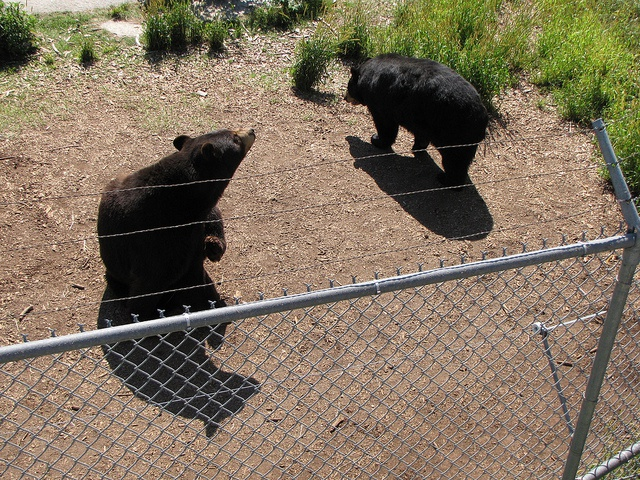Describe the objects in this image and their specific colors. I can see bear in gray, black, and maroon tones and bear in gray and black tones in this image. 